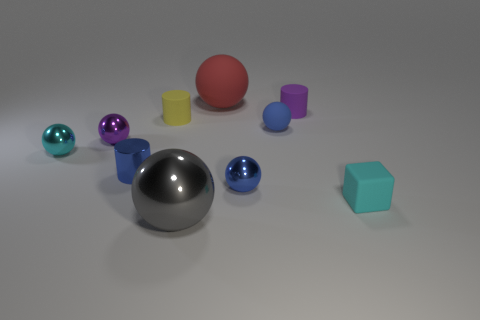Subtract all red spheres. How many spheres are left? 5 Subtract all red rubber balls. How many balls are left? 5 Subtract all yellow balls. Subtract all blue cylinders. How many balls are left? 6 Subtract all cubes. How many objects are left? 9 Add 7 tiny purple cylinders. How many tiny purple cylinders are left? 8 Add 9 large blue shiny blocks. How many large blue shiny blocks exist? 9 Subtract 0 yellow spheres. How many objects are left? 10 Subtract all small blue matte things. Subtract all tiny matte blocks. How many objects are left? 8 